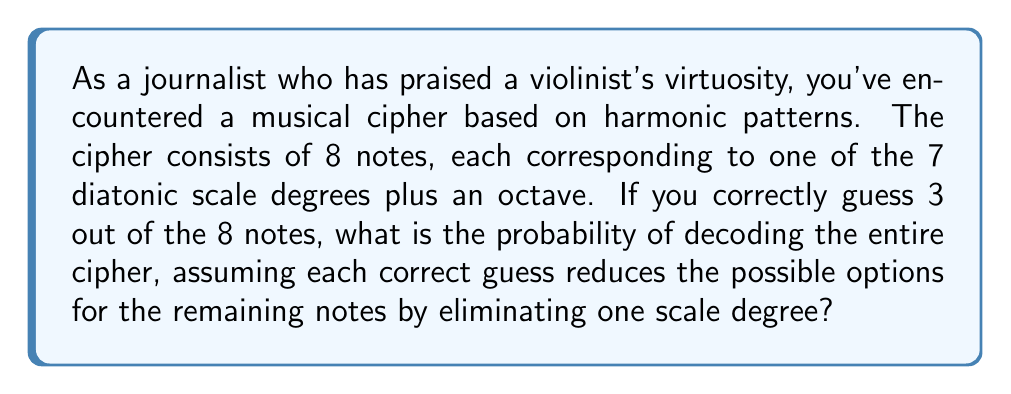Give your solution to this math problem. Let's approach this step-by-step:

1) Initially, there are 8 notes, each with 8 possible options (7 scale degrees + octave).

2) After correctly guessing 3 notes, we have 5 notes left to decode, and each of these has only 5 options left (8 - 3 = 5).

3) The probability of correctly guessing the remaining 5 notes is:

   $$ P = \frac{1}{5} \times \frac{1}{5} \times \frac{1}{5} \times \frac{1}{5} \times \frac{1}{5} = \left(\frac{1}{5}\right)^5 $$

4) To calculate this:
   $$ \left(\frac{1}{5}\right)^5 = \frac{1}{3125} = 0.00032 $$

5) To express this as a percentage:
   $$ 0.00032 \times 100\% = 0.032\% $$

Therefore, the probability of decoding the entire cipher after correctly guessing 3 out of 8 notes is 0.032%.
Answer: 0.032% 